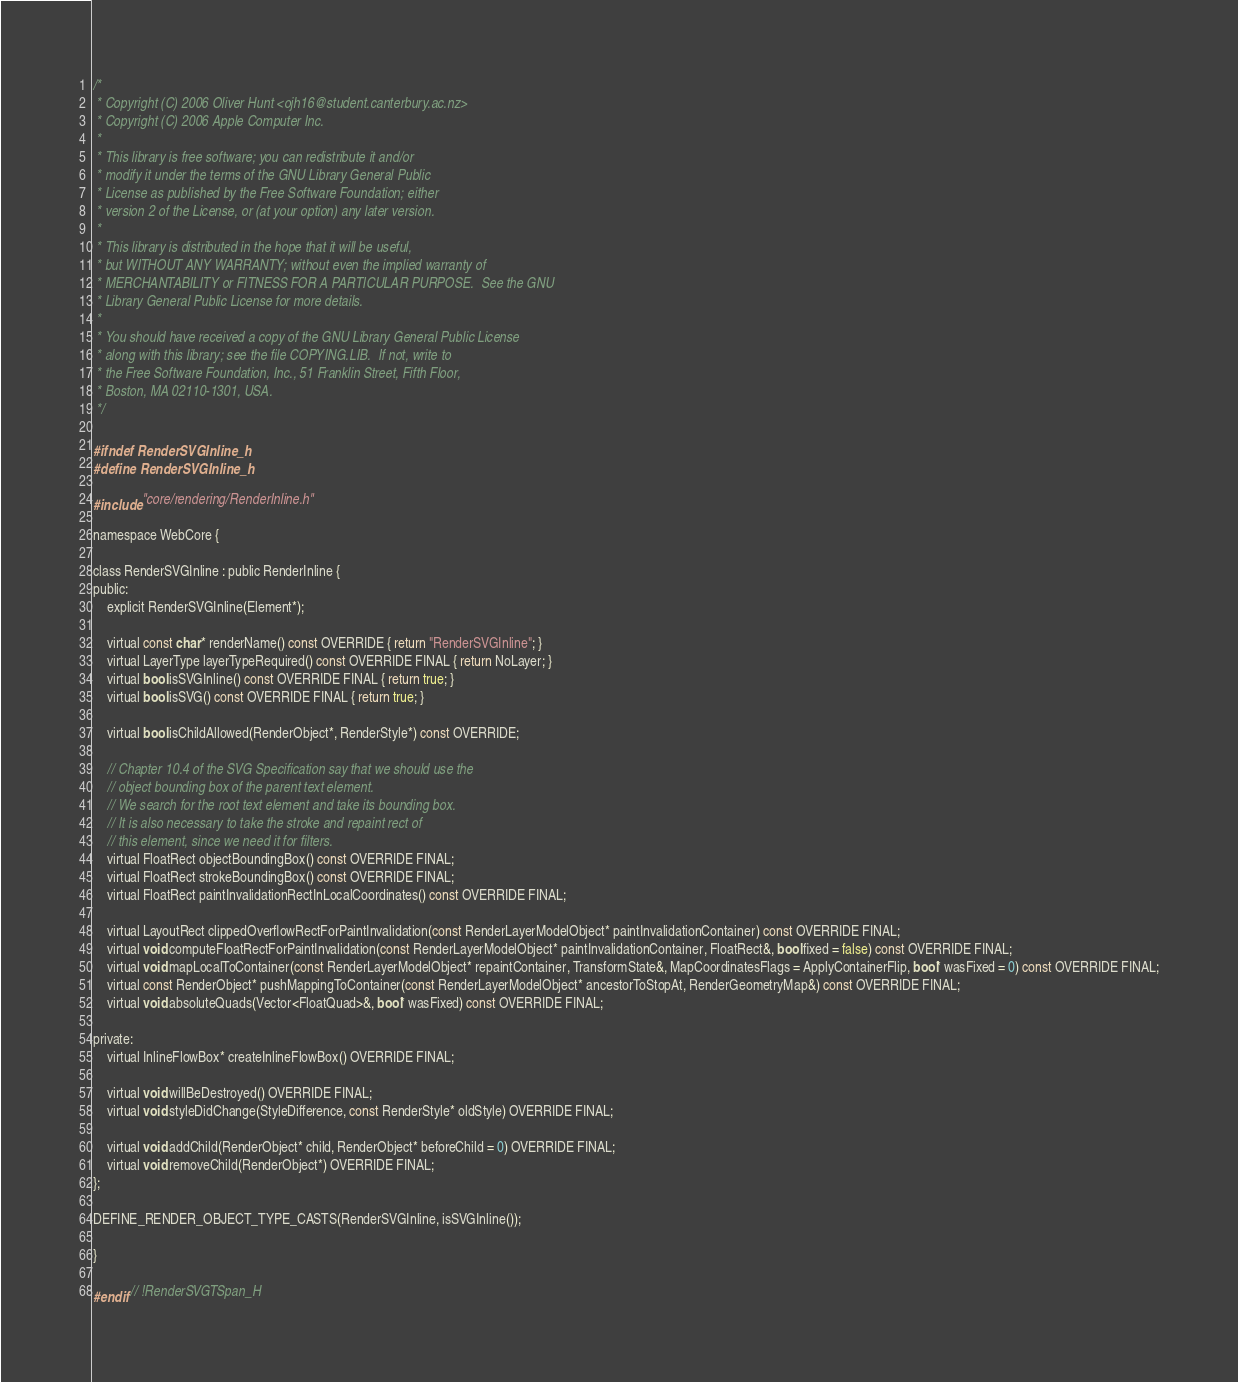<code> <loc_0><loc_0><loc_500><loc_500><_C_>/*
 * Copyright (C) 2006 Oliver Hunt <ojh16@student.canterbury.ac.nz>
 * Copyright (C) 2006 Apple Computer Inc.
 *
 * This library is free software; you can redistribute it and/or
 * modify it under the terms of the GNU Library General Public
 * License as published by the Free Software Foundation; either
 * version 2 of the License, or (at your option) any later version.
 *
 * This library is distributed in the hope that it will be useful,
 * but WITHOUT ANY WARRANTY; without even the implied warranty of
 * MERCHANTABILITY or FITNESS FOR A PARTICULAR PURPOSE.  See the GNU
 * Library General Public License for more details.
 *
 * You should have received a copy of the GNU Library General Public License
 * along with this library; see the file COPYING.LIB.  If not, write to
 * the Free Software Foundation, Inc., 51 Franklin Street, Fifth Floor,
 * Boston, MA 02110-1301, USA.
 */

#ifndef RenderSVGInline_h
#define RenderSVGInline_h

#include "core/rendering/RenderInline.h"

namespace WebCore {

class RenderSVGInline : public RenderInline {
public:
    explicit RenderSVGInline(Element*);

    virtual const char* renderName() const OVERRIDE { return "RenderSVGInline"; }
    virtual LayerType layerTypeRequired() const OVERRIDE FINAL { return NoLayer; }
    virtual bool isSVGInline() const OVERRIDE FINAL { return true; }
    virtual bool isSVG() const OVERRIDE FINAL { return true; }

    virtual bool isChildAllowed(RenderObject*, RenderStyle*) const OVERRIDE;

    // Chapter 10.4 of the SVG Specification say that we should use the
    // object bounding box of the parent text element.
    // We search for the root text element and take its bounding box.
    // It is also necessary to take the stroke and repaint rect of
    // this element, since we need it for filters.
    virtual FloatRect objectBoundingBox() const OVERRIDE FINAL;
    virtual FloatRect strokeBoundingBox() const OVERRIDE FINAL;
    virtual FloatRect paintInvalidationRectInLocalCoordinates() const OVERRIDE FINAL;

    virtual LayoutRect clippedOverflowRectForPaintInvalidation(const RenderLayerModelObject* paintInvalidationContainer) const OVERRIDE FINAL;
    virtual void computeFloatRectForPaintInvalidation(const RenderLayerModelObject* paintInvalidationContainer, FloatRect&, bool fixed = false) const OVERRIDE FINAL;
    virtual void mapLocalToContainer(const RenderLayerModelObject* repaintContainer, TransformState&, MapCoordinatesFlags = ApplyContainerFlip, bool* wasFixed = 0) const OVERRIDE FINAL;
    virtual const RenderObject* pushMappingToContainer(const RenderLayerModelObject* ancestorToStopAt, RenderGeometryMap&) const OVERRIDE FINAL;
    virtual void absoluteQuads(Vector<FloatQuad>&, bool* wasFixed) const OVERRIDE FINAL;

private:
    virtual InlineFlowBox* createInlineFlowBox() OVERRIDE FINAL;

    virtual void willBeDestroyed() OVERRIDE FINAL;
    virtual void styleDidChange(StyleDifference, const RenderStyle* oldStyle) OVERRIDE FINAL;

    virtual void addChild(RenderObject* child, RenderObject* beforeChild = 0) OVERRIDE FINAL;
    virtual void removeChild(RenderObject*) OVERRIDE FINAL;
};

DEFINE_RENDER_OBJECT_TYPE_CASTS(RenderSVGInline, isSVGInline());

}

#endif // !RenderSVGTSpan_H
</code> 